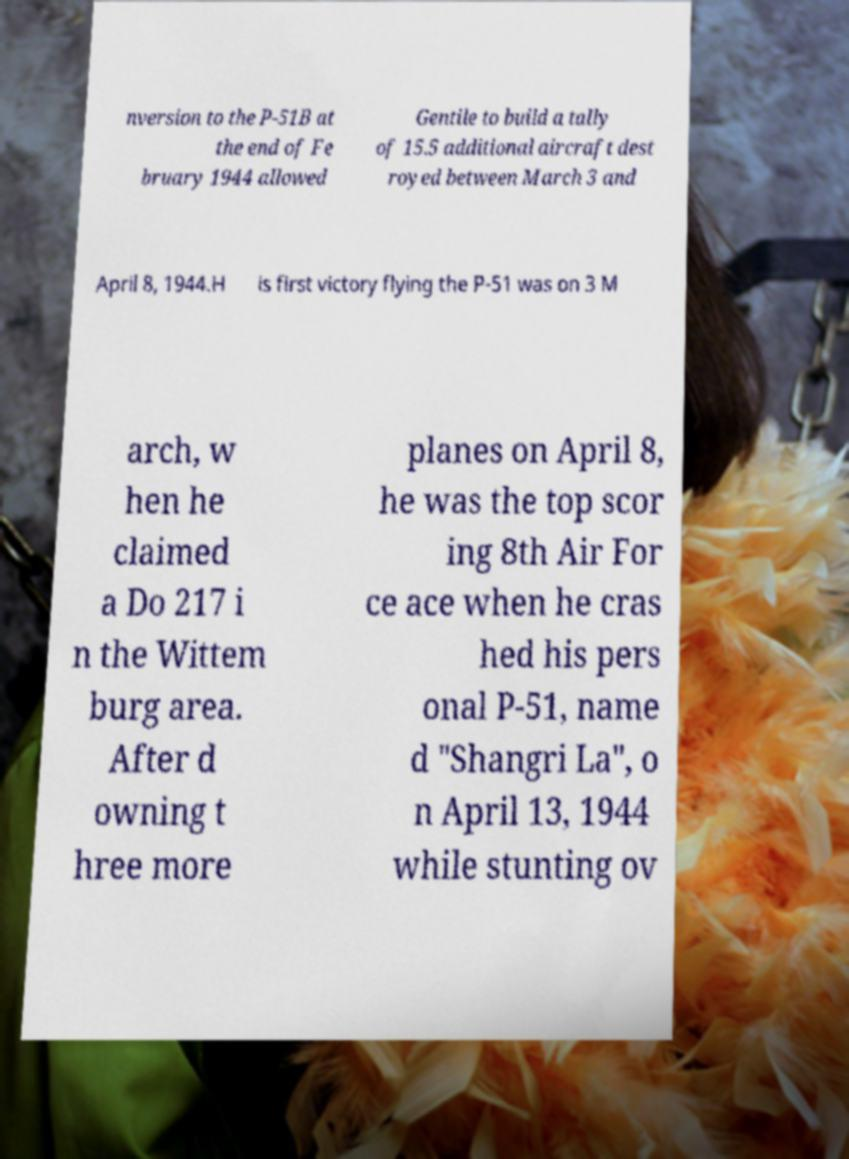What messages or text are displayed in this image? I need them in a readable, typed format. nversion to the P-51B at the end of Fe bruary 1944 allowed Gentile to build a tally of 15.5 additional aircraft dest royed between March 3 and April 8, 1944.H is first victory flying the P-51 was on 3 M arch, w hen he claimed a Do 217 i n the Wittem burg area. After d owning t hree more planes on April 8, he was the top scor ing 8th Air For ce ace when he cras hed his pers onal P-51, name d "Shangri La", o n April 13, 1944 while stunting ov 